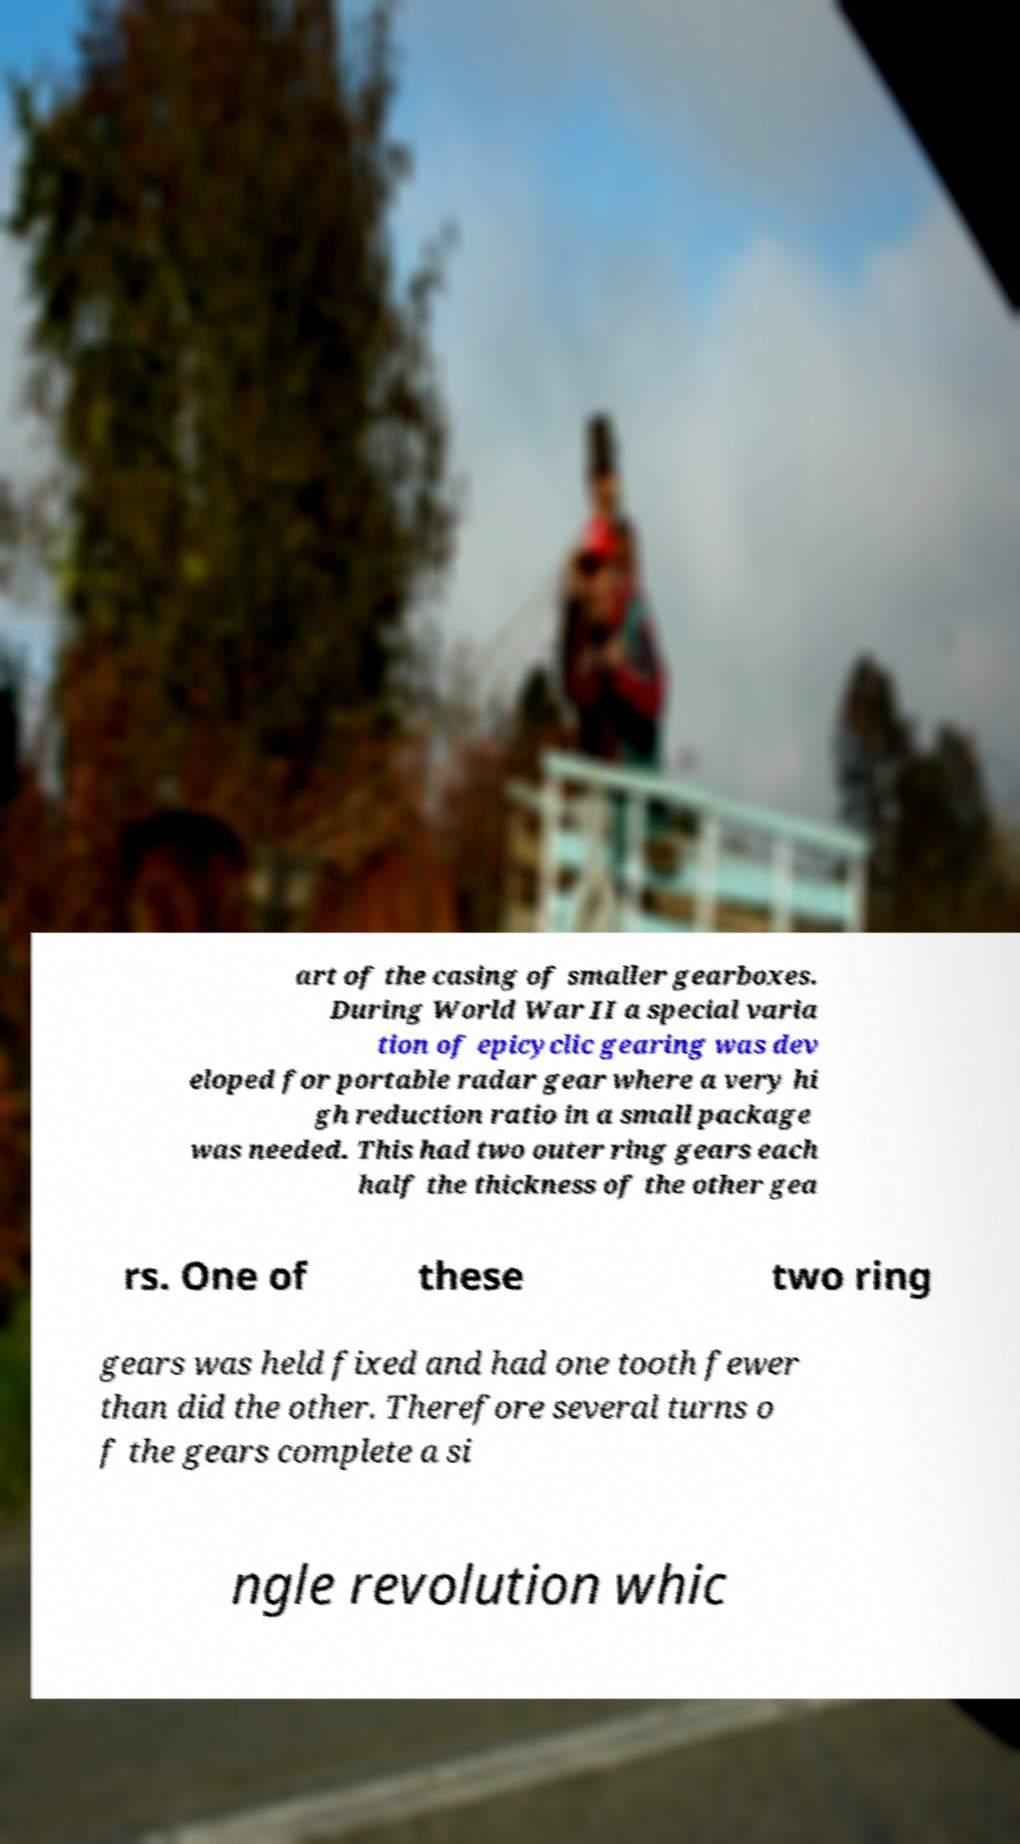What messages or text are displayed in this image? I need them in a readable, typed format. art of the casing of smaller gearboxes. During World War II a special varia tion of epicyclic gearing was dev eloped for portable radar gear where a very hi gh reduction ratio in a small package was needed. This had two outer ring gears each half the thickness of the other gea rs. One of these two ring gears was held fixed and had one tooth fewer than did the other. Therefore several turns o f the gears complete a si ngle revolution whic 